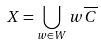<formula> <loc_0><loc_0><loc_500><loc_500>X = \bigcup _ { w \in W } w \overline { C }</formula> 